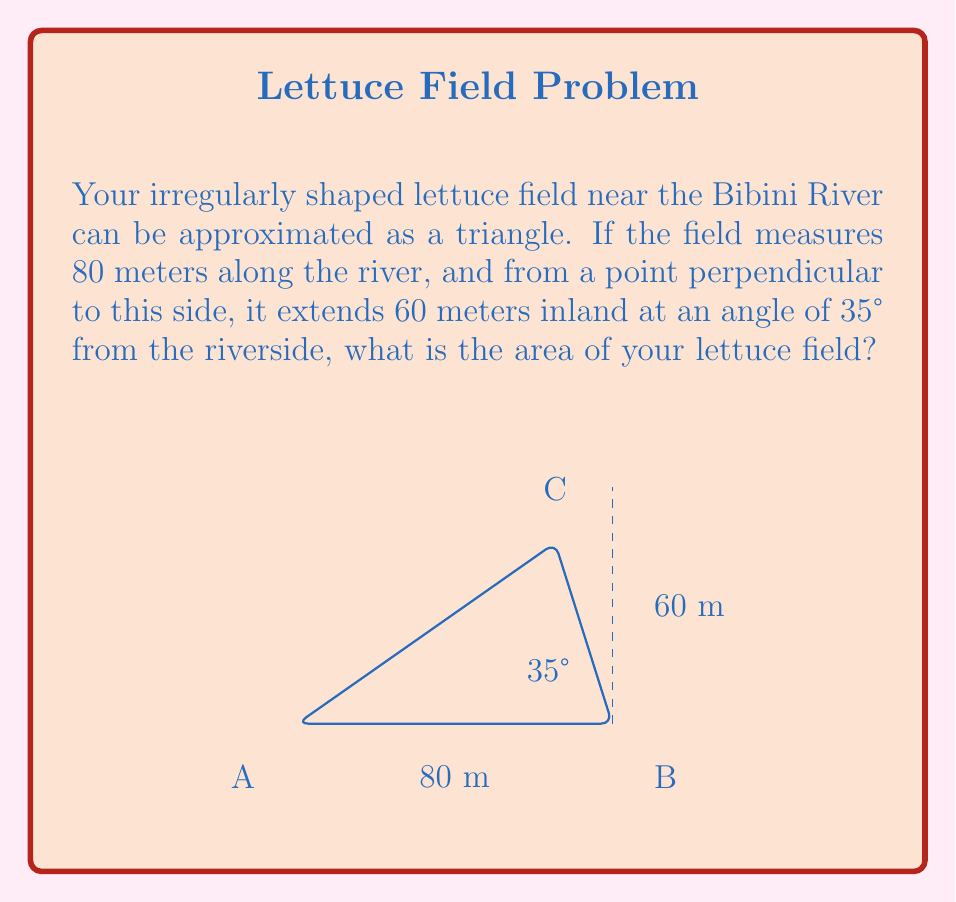Could you help me with this problem? Let's approach this step-by-step:

1) We can use the trigonometric area formula for a triangle: 
   
   $$A = \frac{1}{2}ab\sin(C)$$
   
   where $a$ and $b$ are two sides of the triangle, and $C$ is the angle between them.

2) We know one side of the triangle (along the river) is 80 meters. This will be our $a$.

3) We need to find the length of the other side ($b$). We can do this using the sine function:
   
   $$\sin(35°) = \frac{60}{b}$$

4) Solving for $b$:
   
   $$b = \frac{60}{\sin(35°)} \approx 104.47 \text{ meters}$$

5) Now we have $a = 80$, $b \approx 104.47$, and $C = 35°$.

6) Plugging these into our area formula:

   $$A = \frac{1}{2} \cdot 80 \cdot 104.47 \cdot \sin(35°)$$

7) Calculating this:
   
   $$A \approx 2400 \text{ square meters}$$

Thus, the area of your lettuce field is approximately 2400 square meters.
Answer: $$2400 \text{ m}^2$$ 